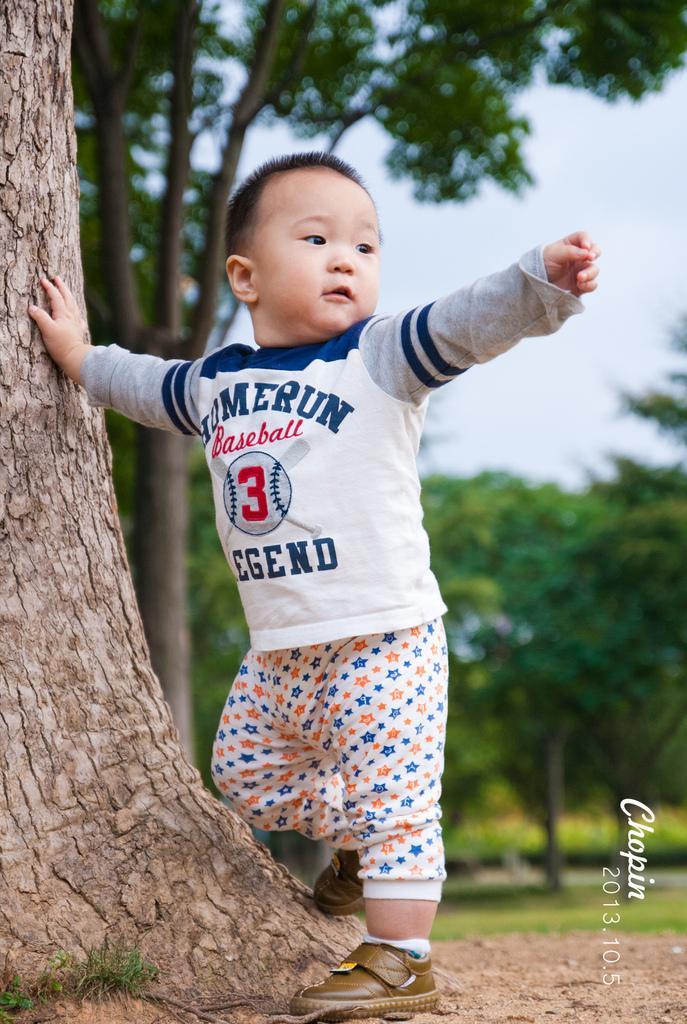In one or two sentences, can you explain what this image depicts? In this image we can see a child standing on the ground and touching the trunk of a tree. In the background we can see sky and trees. 